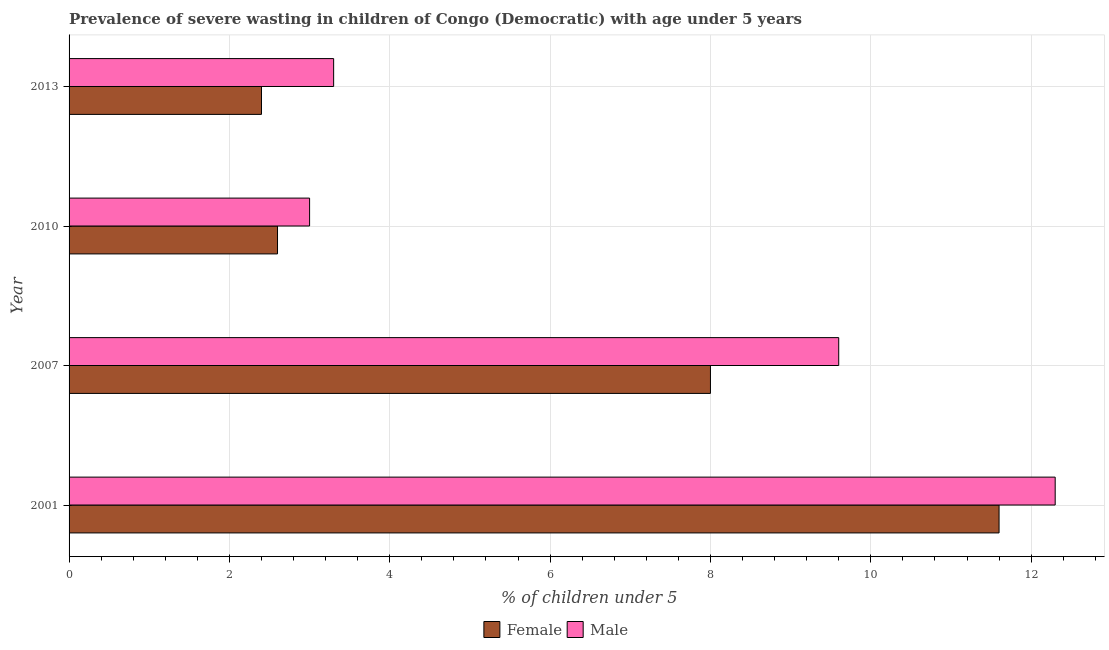How many different coloured bars are there?
Offer a very short reply. 2. Are the number of bars per tick equal to the number of legend labels?
Make the answer very short. Yes. Are the number of bars on each tick of the Y-axis equal?
Ensure brevity in your answer.  Yes. How many bars are there on the 4th tick from the top?
Your answer should be very brief. 2. What is the percentage of undernourished female children in 2001?
Your answer should be very brief. 11.6. Across all years, what is the maximum percentage of undernourished male children?
Provide a short and direct response. 12.3. In which year was the percentage of undernourished female children maximum?
Your response must be concise. 2001. What is the total percentage of undernourished male children in the graph?
Your answer should be compact. 28.2. What is the difference between the percentage of undernourished female children in 2010 and the percentage of undernourished male children in 2001?
Provide a short and direct response. -9.7. What is the average percentage of undernourished female children per year?
Ensure brevity in your answer.  6.15. In how many years, is the percentage of undernourished female children greater than 8 %?
Your answer should be compact. 1. Is the percentage of undernourished female children in 2007 less than that in 2010?
Provide a short and direct response. No. Is the difference between the percentage of undernourished male children in 2010 and 2013 greater than the difference between the percentage of undernourished female children in 2010 and 2013?
Give a very brief answer. No. What is the difference between the highest and the second highest percentage of undernourished male children?
Offer a very short reply. 2.7. What is the difference between the highest and the lowest percentage of undernourished female children?
Make the answer very short. 9.2. How many bars are there?
Offer a very short reply. 8. Are all the bars in the graph horizontal?
Ensure brevity in your answer.  Yes. What is the difference between two consecutive major ticks on the X-axis?
Your response must be concise. 2. Does the graph contain any zero values?
Provide a succinct answer. No. Does the graph contain grids?
Your answer should be very brief. Yes. Where does the legend appear in the graph?
Your answer should be compact. Bottom center. How many legend labels are there?
Give a very brief answer. 2. What is the title of the graph?
Ensure brevity in your answer.  Prevalence of severe wasting in children of Congo (Democratic) with age under 5 years. What is the label or title of the X-axis?
Keep it short and to the point.  % of children under 5. What is the label or title of the Y-axis?
Offer a terse response. Year. What is the  % of children under 5 of Female in 2001?
Give a very brief answer. 11.6. What is the  % of children under 5 in Male in 2001?
Your response must be concise. 12.3. What is the  % of children under 5 in Female in 2007?
Offer a terse response. 8. What is the  % of children under 5 of Male in 2007?
Keep it short and to the point. 9.6. What is the  % of children under 5 in Female in 2010?
Your answer should be very brief. 2.6. What is the  % of children under 5 in Female in 2013?
Provide a short and direct response. 2.4. What is the  % of children under 5 of Male in 2013?
Provide a succinct answer. 3.3. Across all years, what is the maximum  % of children under 5 in Female?
Offer a very short reply. 11.6. Across all years, what is the maximum  % of children under 5 in Male?
Ensure brevity in your answer.  12.3. Across all years, what is the minimum  % of children under 5 in Female?
Provide a short and direct response. 2.4. What is the total  % of children under 5 of Female in the graph?
Make the answer very short. 24.6. What is the total  % of children under 5 of Male in the graph?
Provide a succinct answer. 28.2. What is the difference between the  % of children under 5 in Male in 2001 and that in 2007?
Provide a succinct answer. 2.7. What is the difference between the  % of children under 5 in Female in 2001 and that in 2010?
Provide a short and direct response. 9. What is the difference between the  % of children under 5 of Female in 2001 and that in 2013?
Your answer should be compact. 9.2. What is the difference between the  % of children under 5 in Male in 2001 and that in 2013?
Keep it short and to the point. 9. What is the difference between the  % of children under 5 in Male in 2007 and that in 2010?
Give a very brief answer. 6.6. What is the difference between the  % of children under 5 in Female in 2007 and that in 2013?
Make the answer very short. 5.6. What is the difference between the  % of children under 5 in Female in 2010 and that in 2013?
Ensure brevity in your answer.  0.2. What is the difference between the  % of children under 5 of Female in 2001 and the  % of children under 5 of Male in 2007?
Make the answer very short. 2. What is the difference between the  % of children under 5 of Female in 2007 and the  % of children under 5 of Male in 2010?
Ensure brevity in your answer.  5. What is the average  % of children under 5 in Female per year?
Offer a very short reply. 6.15. What is the average  % of children under 5 of Male per year?
Ensure brevity in your answer.  7.05. In the year 2001, what is the difference between the  % of children under 5 of Female and  % of children under 5 of Male?
Give a very brief answer. -0.7. In the year 2010, what is the difference between the  % of children under 5 in Female and  % of children under 5 in Male?
Provide a short and direct response. -0.4. What is the ratio of the  % of children under 5 in Female in 2001 to that in 2007?
Provide a succinct answer. 1.45. What is the ratio of the  % of children under 5 in Male in 2001 to that in 2007?
Ensure brevity in your answer.  1.28. What is the ratio of the  % of children under 5 of Female in 2001 to that in 2010?
Give a very brief answer. 4.46. What is the ratio of the  % of children under 5 in Female in 2001 to that in 2013?
Offer a terse response. 4.83. What is the ratio of the  % of children under 5 in Male in 2001 to that in 2013?
Your answer should be compact. 3.73. What is the ratio of the  % of children under 5 in Female in 2007 to that in 2010?
Keep it short and to the point. 3.08. What is the ratio of the  % of children under 5 of Female in 2007 to that in 2013?
Keep it short and to the point. 3.33. What is the ratio of the  % of children under 5 in Male in 2007 to that in 2013?
Ensure brevity in your answer.  2.91. What is the ratio of the  % of children under 5 of Female in 2010 to that in 2013?
Provide a short and direct response. 1.08. What is the ratio of the  % of children under 5 of Male in 2010 to that in 2013?
Provide a short and direct response. 0.91. What is the difference between the highest and the lowest  % of children under 5 in Female?
Make the answer very short. 9.2. What is the difference between the highest and the lowest  % of children under 5 in Male?
Keep it short and to the point. 9.3. 